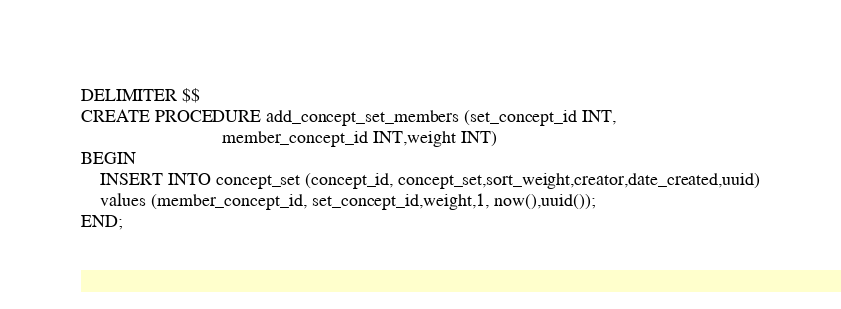<code> <loc_0><loc_0><loc_500><loc_500><_SQL_>DELIMITER $$
CREATE PROCEDURE add_concept_set_members (set_concept_id INT,
                              member_concept_id INT,weight INT)
BEGIN
	INSERT INTO concept_set (concept_id, concept_set,sort_weight,creator,date_created,uuid)
	values (member_concept_id, set_concept_id,weight,1, now(),uuid());
END;



</code> 